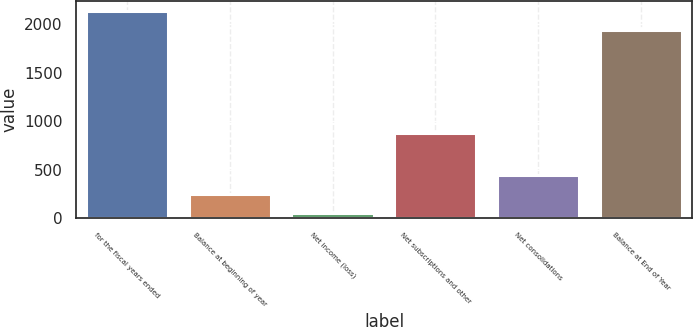Convert chart. <chart><loc_0><loc_0><loc_500><loc_500><bar_chart><fcel>for the fiscal years ended<fcel>Balance at beginning of year<fcel>Net income (loss)<fcel>Net subscriptions and other<fcel>Net consolidations<fcel>Balance at End of Year<nl><fcel>2138.3<fcel>249.4<fcel>53<fcel>884.3<fcel>445.8<fcel>1941.9<nl></chart> 